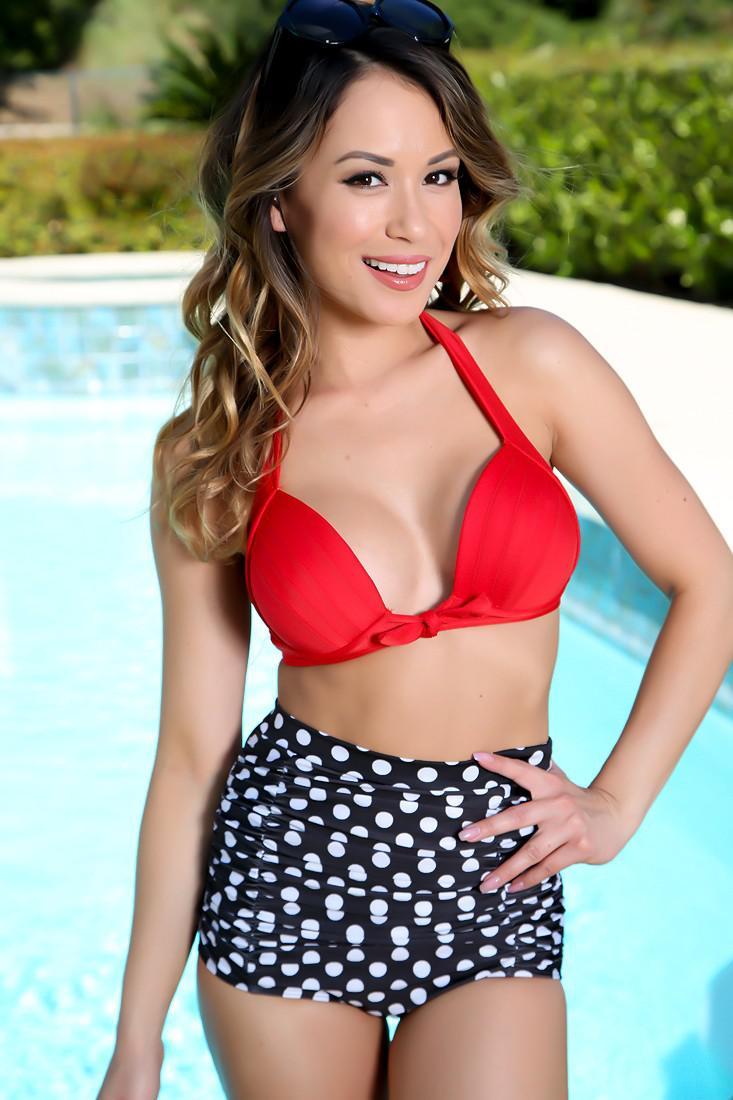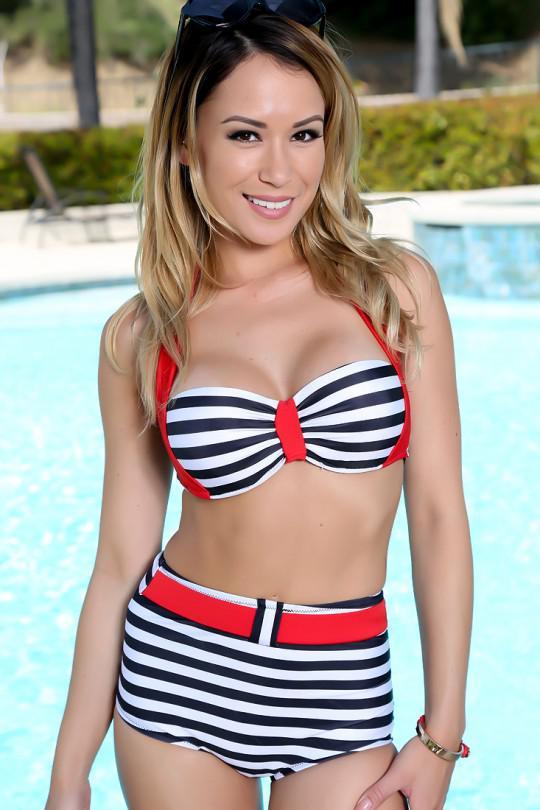The first image is the image on the left, the second image is the image on the right. For the images shown, is this caption "In the left image, the swimsuit top does not match the bottom." true? Answer yes or no. Yes. The first image is the image on the left, the second image is the image on the right. For the images displayed, is the sentence "One model poses in a bikini with horizontal stripes on the top and bottom." factually correct? Answer yes or no. Yes. 